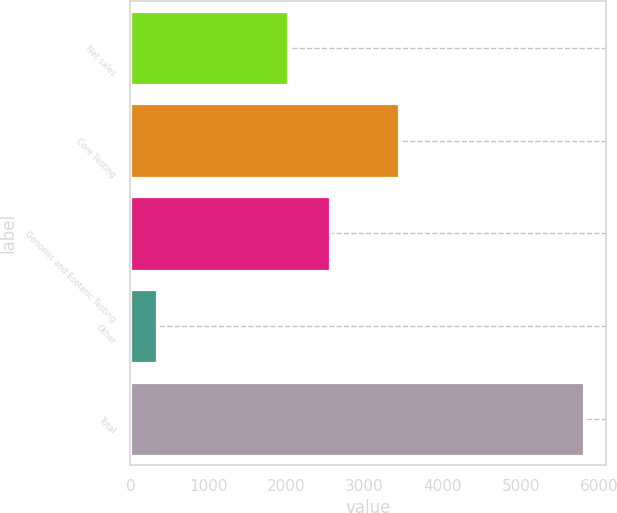Convert chart. <chart><loc_0><loc_0><loc_500><loc_500><bar_chart><fcel>Net sales<fcel>Core Testing<fcel>Genomic and Esoteric Testing<fcel>Other<fcel>Total<nl><fcel>2013<fcel>3445.1<fcel>2559.52<fcel>343.1<fcel>5808.3<nl></chart> 